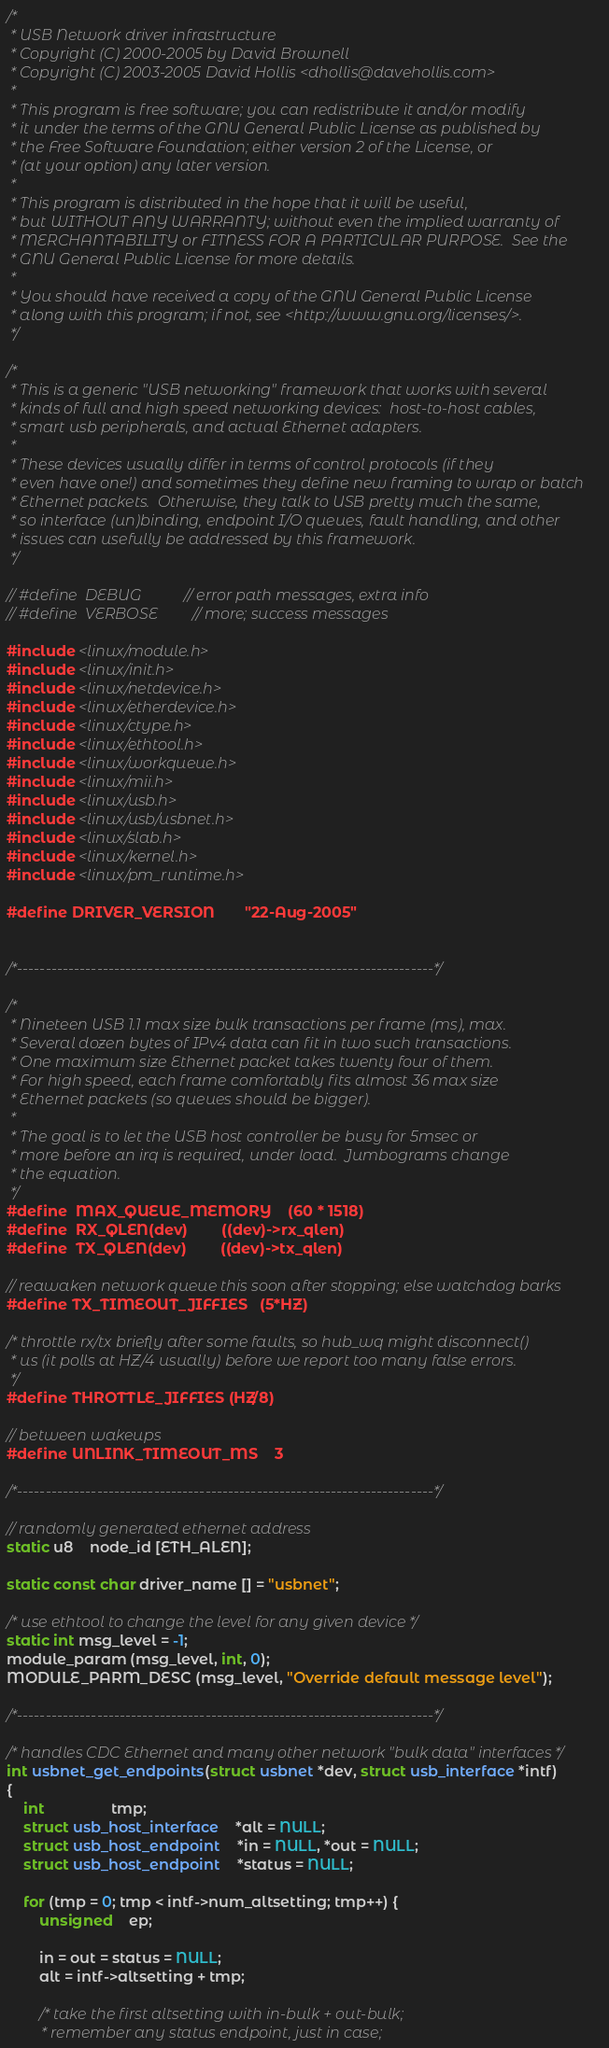<code> <loc_0><loc_0><loc_500><loc_500><_C_>/*
 * USB Network driver infrastructure
 * Copyright (C) 2000-2005 by David Brownell
 * Copyright (C) 2003-2005 David Hollis <dhollis@davehollis.com>
 *
 * This program is free software; you can redistribute it and/or modify
 * it under the terms of the GNU General Public License as published by
 * the Free Software Foundation; either version 2 of the License, or
 * (at your option) any later version.
 *
 * This program is distributed in the hope that it will be useful,
 * but WITHOUT ANY WARRANTY; without even the implied warranty of
 * MERCHANTABILITY or FITNESS FOR A PARTICULAR PURPOSE.  See the
 * GNU General Public License for more details.
 *
 * You should have received a copy of the GNU General Public License
 * along with this program; if not, see <http://www.gnu.org/licenses/>.
 */

/*
 * This is a generic "USB networking" framework that works with several
 * kinds of full and high speed networking devices:  host-to-host cables,
 * smart usb peripherals, and actual Ethernet adapters.
 *
 * These devices usually differ in terms of control protocols (if they
 * even have one!) and sometimes they define new framing to wrap or batch
 * Ethernet packets.  Otherwise, they talk to USB pretty much the same,
 * so interface (un)binding, endpoint I/O queues, fault handling, and other
 * issues can usefully be addressed by this framework.
 */

// #define	DEBUG			// error path messages, extra info
// #define	VERBOSE			// more; success messages

#include <linux/module.h>
#include <linux/init.h>
#include <linux/netdevice.h>
#include <linux/etherdevice.h>
#include <linux/ctype.h>
#include <linux/ethtool.h>
#include <linux/workqueue.h>
#include <linux/mii.h>
#include <linux/usb.h>
#include <linux/usb/usbnet.h>
#include <linux/slab.h>
#include <linux/kernel.h>
#include <linux/pm_runtime.h>

#define DRIVER_VERSION		"22-Aug-2005"


/*-------------------------------------------------------------------------*/

/*
 * Nineteen USB 1.1 max size bulk transactions per frame (ms), max.
 * Several dozen bytes of IPv4 data can fit in two such transactions.
 * One maximum size Ethernet packet takes twenty four of them.
 * For high speed, each frame comfortably fits almost 36 max size
 * Ethernet packets (so queues should be bigger).
 *
 * The goal is to let the USB host controller be busy for 5msec or
 * more before an irq is required, under load.  Jumbograms change
 * the equation.
 */
#define	MAX_QUEUE_MEMORY	(60 * 1518)
#define	RX_QLEN(dev)		((dev)->rx_qlen)
#define	TX_QLEN(dev)		((dev)->tx_qlen)

// reawaken network queue this soon after stopping; else watchdog barks
#define TX_TIMEOUT_JIFFIES	(5*HZ)

/* throttle rx/tx briefly after some faults, so hub_wq might disconnect()
 * us (it polls at HZ/4 usually) before we report too many false errors.
 */
#define THROTTLE_JIFFIES	(HZ/8)

// between wakeups
#define UNLINK_TIMEOUT_MS	3

/*-------------------------------------------------------------------------*/

// randomly generated ethernet address
static u8	node_id [ETH_ALEN];

static const char driver_name [] = "usbnet";

/* use ethtool to change the level for any given device */
static int msg_level = -1;
module_param (msg_level, int, 0);
MODULE_PARM_DESC (msg_level, "Override default message level");

/*-------------------------------------------------------------------------*/

/* handles CDC Ethernet and many other network "bulk data" interfaces */
int usbnet_get_endpoints(struct usbnet *dev, struct usb_interface *intf)
{
	int				tmp;
	struct usb_host_interface	*alt = NULL;
	struct usb_host_endpoint	*in = NULL, *out = NULL;
	struct usb_host_endpoint	*status = NULL;

	for (tmp = 0; tmp < intf->num_altsetting; tmp++) {
		unsigned	ep;

		in = out = status = NULL;
		alt = intf->altsetting + tmp;

		/* take the first altsetting with in-bulk + out-bulk;
		 * remember any status endpoint, just in case;</code> 